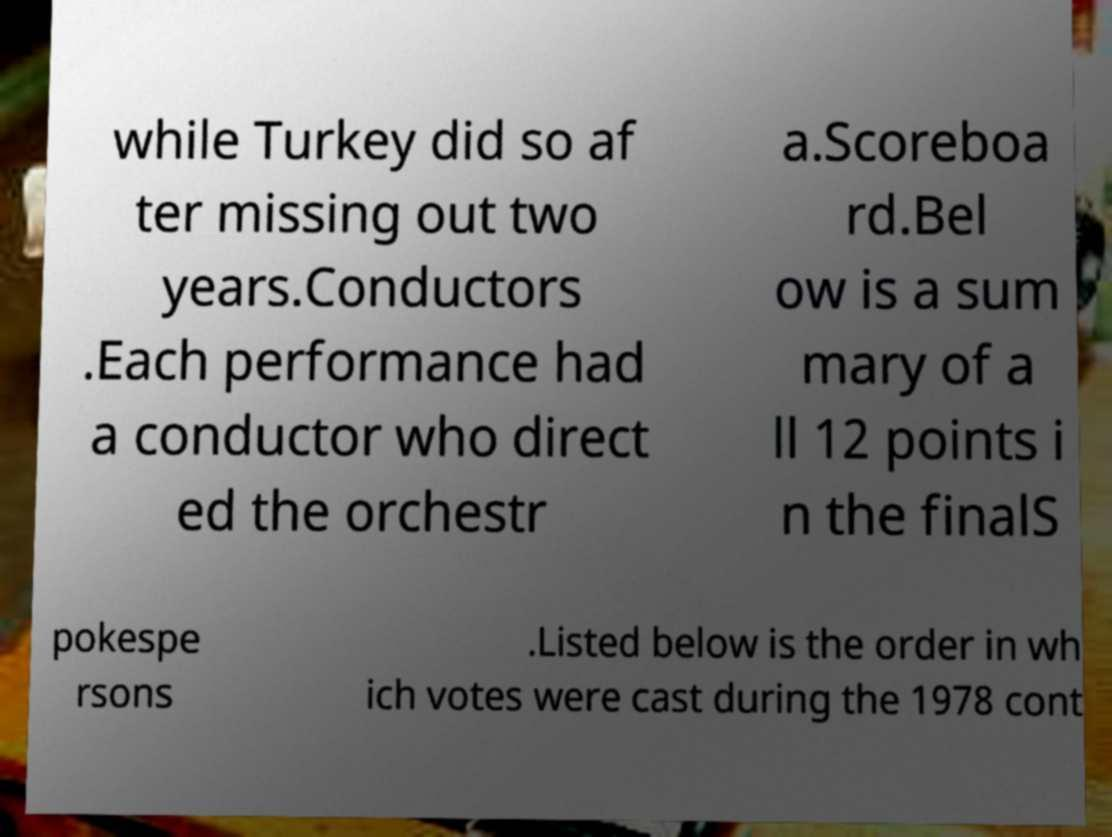I need the written content from this picture converted into text. Can you do that? while Turkey did so af ter missing out two years.Conductors .Each performance had a conductor who direct ed the orchestr a.Scoreboa rd.Bel ow is a sum mary of a ll 12 points i n the finalS pokespe rsons .Listed below is the order in wh ich votes were cast during the 1978 cont 